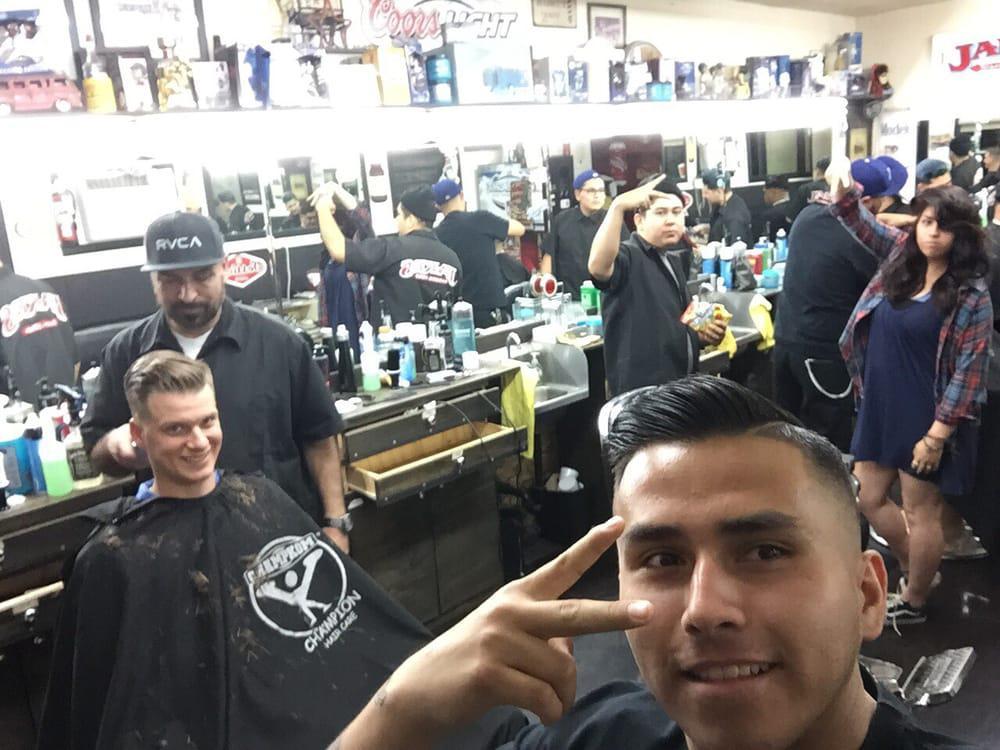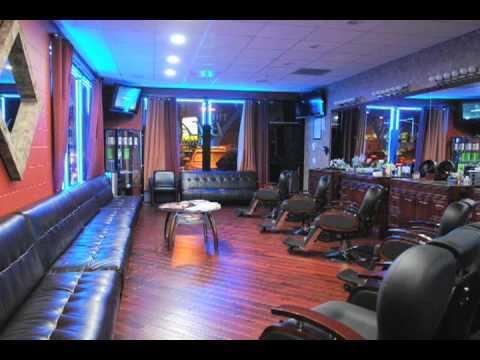The first image is the image on the left, the second image is the image on the right. Examine the images to the left and right. Is the description "The floor of the barbershop in the image on the right has a checkered pattern." accurate? Answer yes or no. No. The first image is the image on the left, the second image is the image on the right. Assess this claim about the two images: "A barbershop in one image has a row of at least four empty barber chairs, with bench seating at the wall behind.". Correct or not? Answer yes or no. Yes. 